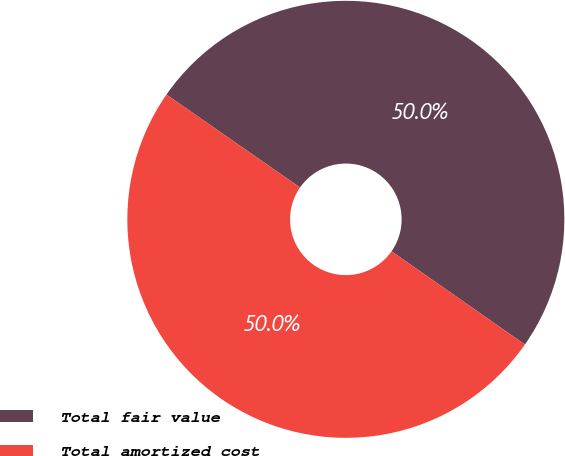Convert chart to OTSL. <chart><loc_0><loc_0><loc_500><loc_500><pie_chart><fcel>Total fair value<fcel>Total amortized cost<nl><fcel>50.04%<fcel>49.96%<nl></chart> 